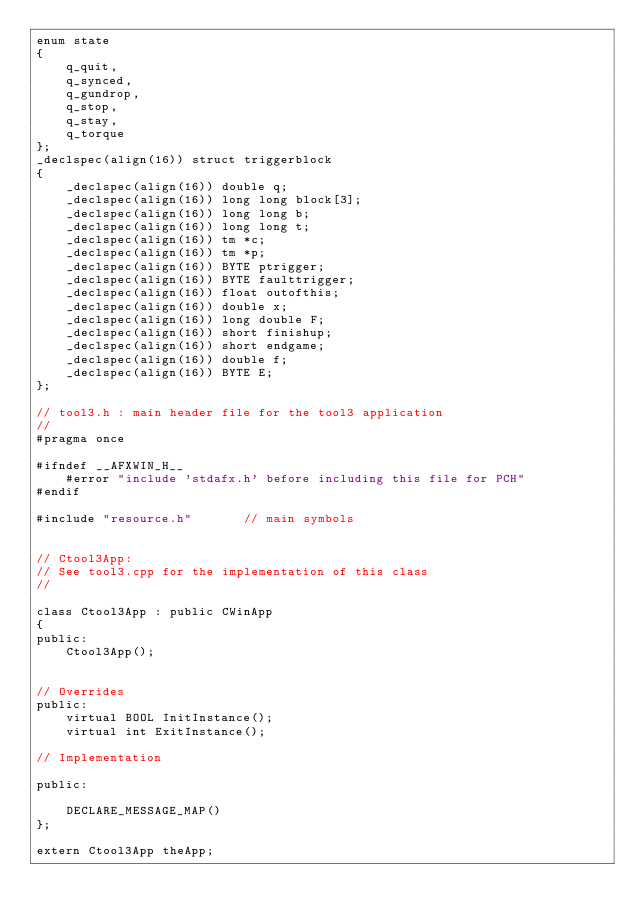<code> <loc_0><loc_0><loc_500><loc_500><_C_>enum state
{
	q_quit,
	q_synced,
	q_gundrop,
	q_stop,
	q_stay,
	q_torque
};
_declspec(align(16)) struct triggerblock 
{	
	_declspec(align(16)) double q;
	_declspec(align(16)) long long block[3];
	_declspec(align(16)) long long b;
	_declspec(align(16)) long long t;
	_declspec(align(16)) tm *c;
	_declspec(align(16)) tm *p;
	_declspec(align(16)) BYTE ptrigger;
	_declspec(align(16)) BYTE faulttrigger;
	_declspec(align(16)) float outofthis;
	_declspec(align(16)) double x;
	_declspec(align(16)) long double F;
	_declspec(align(16)) short finishup;
	_declspec(align(16)) short endgame;
	_declspec(align(16)) double f;
	_declspec(align(16)) BYTE E;
};

// tool3.h : main header file for the tool3 application
//
#pragma once

#ifndef __AFXWIN_H__
	#error "include 'stdafx.h' before including this file for PCH"
#endif

#include "resource.h"       // main symbols


// Ctool3App:
// See tool3.cpp for the implementation of this class
//

class Ctool3App : public CWinApp
{
public:
	Ctool3App();


// Overrides
public:
	virtual BOOL InitInstance();
	virtual int ExitInstance();

// Implementation

public:

	DECLARE_MESSAGE_MAP()
};

extern Ctool3App theApp;
</code> 